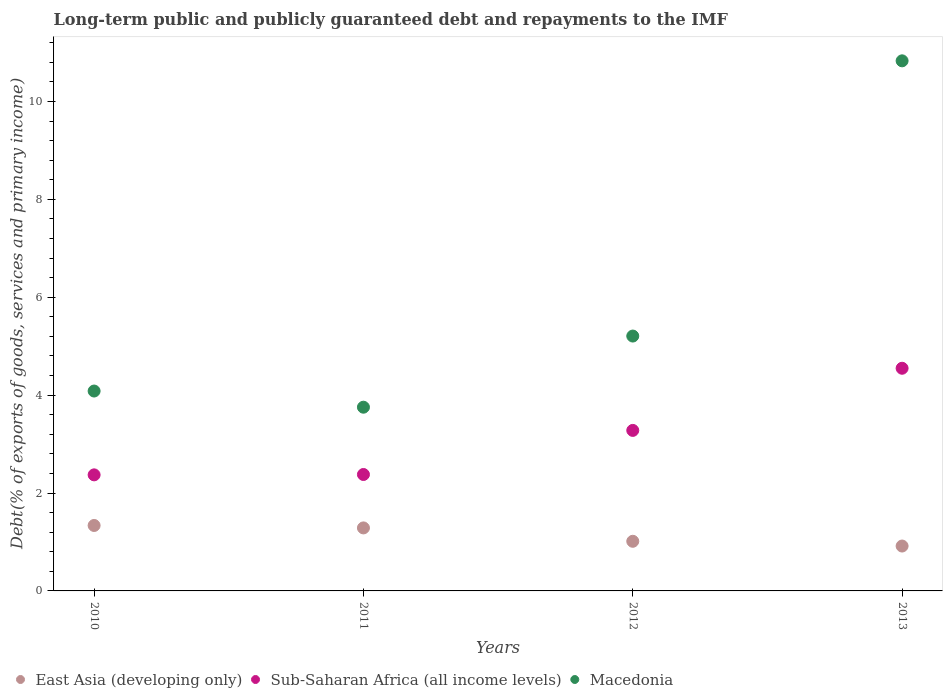How many different coloured dotlines are there?
Your response must be concise. 3. Is the number of dotlines equal to the number of legend labels?
Your answer should be very brief. Yes. What is the debt and repayments in East Asia (developing only) in 2012?
Make the answer very short. 1.01. Across all years, what is the maximum debt and repayments in Macedonia?
Make the answer very short. 10.83. Across all years, what is the minimum debt and repayments in East Asia (developing only)?
Keep it short and to the point. 0.92. In which year was the debt and repayments in Macedonia maximum?
Offer a very short reply. 2013. What is the total debt and repayments in Sub-Saharan Africa (all income levels) in the graph?
Keep it short and to the point. 12.58. What is the difference between the debt and repayments in East Asia (developing only) in 2010 and that in 2011?
Keep it short and to the point. 0.05. What is the difference between the debt and repayments in Macedonia in 2011 and the debt and repayments in Sub-Saharan Africa (all income levels) in 2012?
Give a very brief answer. 0.47. What is the average debt and repayments in East Asia (developing only) per year?
Provide a short and direct response. 1.14. In the year 2010, what is the difference between the debt and repayments in East Asia (developing only) and debt and repayments in Macedonia?
Give a very brief answer. -2.75. In how many years, is the debt and repayments in East Asia (developing only) greater than 8.4 %?
Provide a succinct answer. 0. What is the ratio of the debt and repayments in Sub-Saharan Africa (all income levels) in 2012 to that in 2013?
Your answer should be compact. 0.72. Is the difference between the debt and repayments in East Asia (developing only) in 2010 and 2011 greater than the difference between the debt and repayments in Macedonia in 2010 and 2011?
Provide a succinct answer. No. What is the difference between the highest and the second highest debt and repayments in Macedonia?
Your answer should be compact. 5.62. What is the difference between the highest and the lowest debt and repayments in East Asia (developing only)?
Provide a succinct answer. 0.42. Is the sum of the debt and repayments in Sub-Saharan Africa (all income levels) in 2012 and 2013 greater than the maximum debt and repayments in Macedonia across all years?
Offer a terse response. No. Is the debt and repayments in Sub-Saharan Africa (all income levels) strictly greater than the debt and repayments in East Asia (developing only) over the years?
Give a very brief answer. Yes. Is the debt and repayments in Macedonia strictly less than the debt and repayments in Sub-Saharan Africa (all income levels) over the years?
Provide a succinct answer. No. How many years are there in the graph?
Offer a very short reply. 4. What is the difference between two consecutive major ticks on the Y-axis?
Provide a succinct answer. 2. What is the title of the graph?
Offer a terse response. Long-term public and publicly guaranteed debt and repayments to the IMF. What is the label or title of the X-axis?
Your answer should be compact. Years. What is the label or title of the Y-axis?
Make the answer very short. Debt(% of exports of goods, services and primary income). What is the Debt(% of exports of goods, services and primary income) of East Asia (developing only) in 2010?
Your answer should be compact. 1.34. What is the Debt(% of exports of goods, services and primary income) of Sub-Saharan Africa (all income levels) in 2010?
Ensure brevity in your answer.  2.37. What is the Debt(% of exports of goods, services and primary income) in Macedonia in 2010?
Your answer should be compact. 4.08. What is the Debt(% of exports of goods, services and primary income) in East Asia (developing only) in 2011?
Offer a terse response. 1.29. What is the Debt(% of exports of goods, services and primary income) of Sub-Saharan Africa (all income levels) in 2011?
Make the answer very short. 2.38. What is the Debt(% of exports of goods, services and primary income) in Macedonia in 2011?
Keep it short and to the point. 3.75. What is the Debt(% of exports of goods, services and primary income) of East Asia (developing only) in 2012?
Your response must be concise. 1.01. What is the Debt(% of exports of goods, services and primary income) in Sub-Saharan Africa (all income levels) in 2012?
Your answer should be compact. 3.28. What is the Debt(% of exports of goods, services and primary income) in Macedonia in 2012?
Provide a short and direct response. 5.21. What is the Debt(% of exports of goods, services and primary income) of East Asia (developing only) in 2013?
Ensure brevity in your answer.  0.92. What is the Debt(% of exports of goods, services and primary income) in Sub-Saharan Africa (all income levels) in 2013?
Your response must be concise. 4.55. What is the Debt(% of exports of goods, services and primary income) of Macedonia in 2013?
Make the answer very short. 10.83. Across all years, what is the maximum Debt(% of exports of goods, services and primary income) in East Asia (developing only)?
Provide a short and direct response. 1.34. Across all years, what is the maximum Debt(% of exports of goods, services and primary income) in Sub-Saharan Africa (all income levels)?
Give a very brief answer. 4.55. Across all years, what is the maximum Debt(% of exports of goods, services and primary income) in Macedonia?
Offer a terse response. 10.83. Across all years, what is the minimum Debt(% of exports of goods, services and primary income) of East Asia (developing only)?
Keep it short and to the point. 0.92. Across all years, what is the minimum Debt(% of exports of goods, services and primary income) in Sub-Saharan Africa (all income levels)?
Your answer should be very brief. 2.37. Across all years, what is the minimum Debt(% of exports of goods, services and primary income) of Macedonia?
Give a very brief answer. 3.75. What is the total Debt(% of exports of goods, services and primary income) of East Asia (developing only) in the graph?
Provide a short and direct response. 4.56. What is the total Debt(% of exports of goods, services and primary income) in Sub-Saharan Africa (all income levels) in the graph?
Give a very brief answer. 12.58. What is the total Debt(% of exports of goods, services and primary income) of Macedonia in the graph?
Offer a very short reply. 23.87. What is the difference between the Debt(% of exports of goods, services and primary income) of East Asia (developing only) in 2010 and that in 2011?
Keep it short and to the point. 0.05. What is the difference between the Debt(% of exports of goods, services and primary income) of Sub-Saharan Africa (all income levels) in 2010 and that in 2011?
Make the answer very short. -0.01. What is the difference between the Debt(% of exports of goods, services and primary income) of Macedonia in 2010 and that in 2011?
Provide a short and direct response. 0.33. What is the difference between the Debt(% of exports of goods, services and primary income) in East Asia (developing only) in 2010 and that in 2012?
Your answer should be very brief. 0.32. What is the difference between the Debt(% of exports of goods, services and primary income) of Sub-Saharan Africa (all income levels) in 2010 and that in 2012?
Make the answer very short. -0.91. What is the difference between the Debt(% of exports of goods, services and primary income) in Macedonia in 2010 and that in 2012?
Keep it short and to the point. -1.12. What is the difference between the Debt(% of exports of goods, services and primary income) of East Asia (developing only) in 2010 and that in 2013?
Make the answer very short. 0.42. What is the difference between the Debt(% of exports of goods, services and primary income) of Sub-Saharan Africa (all income levels) in 2010 and that in 2013?
Provide a short and direct response. -2.18. What is the difference between the Debt(% of exports of goods, services and primary income) of Macedonia in 2010 and that in 2013?
Provide a short and direct response. -6.75. What is the difference between the Debt(% of exports of goods, services and primary income) in East Asia (developing only) in 2011 and that in 2012?
Give a very brief answer. 0.27. What is the difference between the Debt(% of exports of goods, services and primary income) in Sub-Saharan Africa (all income levels) in 2011 and that in 2012?
Your response must be concise. -0.9. What is the difference between the Debt(% of exports of goods, services and primary income) of Macedonia in 2011 and that in 2012?
Provide a succinct answer. -1.45. What is the difference between the Debt(% of exports of goods, services and primary income) of East Asia (developing only) in 2011 and that in 2013?
Provide a short and direct response. 0.37. What is the difference between the Debt(% of exports of goods, services and primary income) in Sub-Saharan Africa (all income levels) in 2011 and that in 2013?
Provide a succinct answer. -2.17. What is the difference between the Debt(% of exports of goods, services and primary income) of Macedonia in 2011 and that in 2013?
Your response must be concise. -7.08. What is the difference between the Debt(% of exports of goods, services and primary income) in East Asia (developing only) in 2012 and that in 2013?
Your response must be concise. 0.1. What is the difference between the Debt(% of exports of goods, services and primary income) of Sub-Saharan Africa (all income levels) in 2012 and that in 2013?
Give a very brief answer. -1.27. What is the difference between the Debt(% of exports of goods, services and primary income) of Macedonia in 2012 and that in 2013?
Offer a terse response. -5.62. What is the difference between the Debt(% of exports of goods, services and primary income) in East Asia (developing only) in 2010 and the Debt(% of exports of goods, services and primary income) in Sub-Saharan Africa (all income levels) in 2011?
Keep it short and to the point. -1.04. What is the difference between the Debt(% of exports of goods, services and primary income) in East Asia (developing only) in 2010 and the Debt(% of exports of goods, services and primary income) in Macedonia in 2011?
Keep it short and to the point. -2.42. What is the difference between the Debt(% of exports of goods, services and primary income) of Sub-Saharan Africa (all income levels) in 2010 and the Debt(% of exports of goods, services and primary income) of Macedonia in 2011?
Provide a short and direct response. -1.38. What is the difference between the Debt(% of exports of goods, services and primary income) of East Asia (developing only) in 2010 and the Debt(% of exports of goods, services and primary income) of Sub-Saharan Africa (all income levels) in 2012?
Ensure brevity in your answer.  -1.94. What is the difference between the Debt(% of exports of goods, services and primary income) in East Asia (developing only) in 2010 and the Debt(% of exports of goods, services and primary income) in Macedonia in 2012?
Ensure brevity in your answer.  -3.87. What is the difference between the Debt(% of exports of goods, services and primary income) of Sub-Saharan Africa (all income levels) in 2010 and the Debt(% of exports of goods, services and primary income) of Macedonia in 2012?
Your response must be concise. -2.84. What is the difference between the Debt(% of exports of goods, services and primary income) of East Asia (developing only) in 2010 and the Debt(% of exports of goods, services and primary income) of Sub-Saharan Africa (all income levels) in 2013?
Provide a short and direct response. -3.21. What is the difference between the Debt(% of exports of goods, services and primary income) in East Asia (developing only) in 2010 and the Debt(% of exports of goods, services and primary income) in Macedonia in 2013?
Make the answer very short. -9.49. What is the difference between the Debt(% of exports of goods, services and primary income) of Sub-Saharan Africa (all income levels) in 2010 and the Debt(% of exports of goods, services and primary income) of Macedonia in 2013?
Provide a succinct answer. -8.46. What is the difference between the Debt(% of exports of goods, services and primary income) of East Asia (developing only) in 2011 and the Debt(% of exports of goods, services and primary income) of Sub-Saharan Africa (all income levels) in 2012?
Your answer should be compact. -1.99. What is the difference between the Debt(% of exports of goods, services and primary income) in East Asia (developing only) in 2011 and the Debt(% of exports of goods, services and primary income) in Macedonia in 2012?
Provide a short and direct response. -3.92. What is the difference between the Debt(% of exports of goods, services and primary income) of Sub-Saharan Africa (all income levels) in 2011 and the Debt(% of exports of goods, services and primary income) of Macedonia in 2012?
Make the answer very short. -2.83. What is the difference between the Debt(% of exports of goods, services and primary income) of East Asia (developing only) in 2011 and the Debt(% of exports of goods, services and primary income) of Sub-Saharan Africa (all income levels) in 2013?
Your response must be concise. -3.26. What is the difference between the Debt(% of exports of goods, services and primary income) in East Asia (developing only) in 2011 and the Debt(% of exports of goods, services and primary income) in Macedonia in 2013?
Offer a very short reply. -9.54. What is the difference between the Debt(% of exports of goods, services and primary income) in Sub-Saharan Africa (all income levels) in 2011 and the Debt(% of exports of goods, services and primary income) in Macedonia in 2013?
Ensure brevity in your answer.  -8.45. What is the difference between the Debt(% of exports of goods, services and primary income) in East Asia (developing only) in 2012 and the Debt(% of exports of goods, services and primary income) in Sub-Saharan Africa (all income levels) in 2013?
Provide a succinct answer. -3.53. What is the difference between the Debt(% of exports of goods, services and primary income) in East Asia (developing only) in 2012 and the Debt(% of exports of goods, services and primary income) in Macedonia in 2013?
Your response must be concise. -9.82. What is the difference between the Debt(% of exports of goods, services and primary income) in Sub-Saharan Africa (all income levels) in 2012 and the Debt(% of exports of goods, services and primary income) in Macedonia in 2013?
Your answer should be very brief. -7.55. What is the average Debt(% of exports of goods, services and primary income) in East Asia (developing only) per year?
Your response must be concise. 1.14. What is the average Debt(% of exports of goods, services and primary income) in Sub-Saharan Africa (all income levels) per year?
Your answer should be compact. 3.14. What is the average Debt(% of exports of goods, services and primary income) of Macedonia per year?
Your answer should be very brief. 5.97. In the year 2010, what is the difference between the Debt(% of exports of goods, services and primary income) in East Asia (developing only) and Debt(% of exports of goods, services and primary income) in Sub-Saharan Africa (all income levels)?
Ensure brevity in your answer.  -1.03. In the year 2010, what is the difference between the Debt(% of exports of goods, services and primary income) of East Asia (developing only) and Debt(% of exports of goods, services and primary income) of Macedonia?
Offer a very short reply. -2.75. In the year 2010, what is the difference between the Debt(% of exports of goods, services and primary income) in Sub-Saharan Africa (all income levels) and Debt(% of exports of goods, services and primary income) in Macedonia?
Provide a succinct answer. -1.71. In the year 2011, what is the difference between the Debt(% of exports of goods, services and primary income) in East Asia (developing only) and Debt(% of exports of goods, services and primary income) in Sub-Saharan Africa (all income levels)?
Offer a terse response. -1.09. In the year 2011, what is the difference between the Debt(% of exports of goods, services and primary income) of East Asia (developing only) and Debt(% of exports of goods, services and primary income) of Macedonia?
Offer a terse response. -2.47. In the year 2011, what is the difference between the Debt(% of exports of goods, services and primary income) of Sub-Saharan Africa (all income levels) and Debt(% of exports of goods, services and primary income) of Macedonia?
Your answer should be very brief. -1.37. In the year 2012, what is the difference between the Debt(% of exports of goods, services and primary income) of East Asia (developing only) and Debt(% of exports of goods, services and primary income) of Sub-Saharan Africa (all income levels)?
Give a very brief answer. -2.27. In the year 2012, what is the difference between the Debt(% of exports of goods, services and primary income) in East Asia (developing only) and Debt(% of exports of goods, services and primary income) in Macedonia?
Offer a terse response. -4.19. In the year 2012, what is the difference between the Debt(% of exports of goods, services and primary income) of Sub-Saharan Africa (all income levels) and Debt(% of exports of goods, services and primary income) of Macedonia?
Give a very brief answer. -1.93. In the year 2013, what is the difference between the Debt(% of exports of goods, services and primary income) in East Asia (developing only) and Debt(% of exports of goods, services and primary income) in Sub-Saharan Africa (all income levels)?
Your response must be concise. -3.63. In the year 2013, what is the difference between the Debt(% of exports of goods, services and primary income) in East Asia (developing only) and Debt(% of exports of goods, services and primary income) in Macedonia?
Provide a succinct answer. -9.91. In the year 2013, what is the difference between the Debt(% of exports of goods, services and primary income) in Sub-Saharan Africa (all income levels) and Debt(% of exports of goods, services and primary income) in Macedonia?
Give a very brief answer. -6.28. What is the ratio of the Debt(% of exports of goods, services and primary income) of East Asia (developing only) in 2010 to that in 2011?
Keep it short and to the point. 1.04. What is the ratio of the Debt(% of exports of goods, services and primary income) of Sub-Saharan Africa (all income levels) in 2010 to that in 2011?
Make the answer very short. 1. What is the ratio of the Debt(% of exports of goods, services and primary income) of Macedonia in 2010 to that in 2011?
Offer a very short reply. 1.09. What is the ratio of the Debt(% of exports of goods, services and primary income) of East Asia (developing only) in 2010 to that in 2012?
Your answer should be very brief. 1.32. What is the ratio of the Debt(% of exports of goods, services and primary income) in Sub-Saharan Africa (all income levels) in 2010 to that in 2012?
Offer a very short reply. 0.72. What is the ratio of the Debt(% of exports of goods, services and primary income) of Macedonia in 2010 to that in 2012?
Ensure brevity in your answer.  0.78. What is the ratio of the Debt(% of exports of goods, services and primary income) in East Asia (developing only) in 2010 to that in 2013?
Offer a terse response. 1.46. What is the ratio of the Debt(% of exports of goods, services and primary income) of Sub-Saharan Africa (all income levels) in 2010 to that in 2013?
Your answer should be compact. 0.52. What is the ratio of the Debt(% of exports of goods, services and primary income) in Macedonia in 2010 to that in 2013?
Offer a very short reply. 0.38. What is the ratio of the Debt(% of exports of goods, services and primary income) of East Asia (developing only) in 2011 to that in 2012?
Your answer should be very brief. 1.27. What is the ratio of the Debt(% of exports of goods, services and primary income) of Sub-Saharan Africa (all income levels) in 2011 to that in 2012?
Provide a short and direct response. 0.73. What is the ratio of the Debt(% of exports of goods, services and primary income) of Macedonia in 2011 to that in 2012?
Give a very brief answer. 0.72. What is the ratio of the Debt(% of exports of goods, services and primary income) of East Asia (developing only) in 2011 to that in 2013?
Keep it short and to the point. 1.4. What is the ratio of the Debt(% of exports of goods, services and primary income) of Sub-Saharan Africa (all income levels) in 2011 to that in 2013?
Offer a very short reply. 0.52. What is the ratio of the Debt(% of exports of goods, services and primary income) in Macedonia in 2011 to that in 2013?
Provide a short and direct response. 0.35. What is the ratio of the Debt(% of exports of goods, services and primary income) in East Asia (developing only) in 2012 to that in 2013?
Provide a succinct answer. 1.11. What is the ratio of the Debt(% of exports of goods, services and primary income) of Sub-Saharan Africa (all income levels) in 2012 to that in 2013?
Your answer should be compact. 0.72. What is the ratio of the Debt(% of exports of goods, services and primary income) of Macedonia in 2012 to that in 2013?
Provide a succinct answer. 0.48. What is the difference between the highest and the second highest Debt(% of exports of goods, services and primary income) in East Asia (developing only)?
Your answer should be very brief. 0.05. What is the difference between the highest and the second highest Debt(% of exports of goods, services and primary income) in Sub-Saharan Africa (all income levels)?
Provide a succinct answer. 1.27. What is the difference between the highest and the second highest Debt(% of exports of goods, services and primary income) of Macedonia?
Your answer should be very brief. 5.62. What is the difference between the highest and the lowest Debt(% of exports of goods, services and primary income) of East Asia (developing only)?
Make the answer very short. 0.42. What is the difference between the highest and the lowest Debt(% of exports of goods, services and primary income) of Sub-Saharan Africa (all income levels)?
Give a very brief answer. 2.18. What is the difference between the highest and the lowest Debt(% of exports of goods, services and primary income) of Macedonia?
Keep it short and to the point. 7.08. 